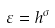Convert formula to latex. <formula><loc_0><loc_0><loc_500><loc_500>\varepsilon = h ^ { \sigma }</formula> 